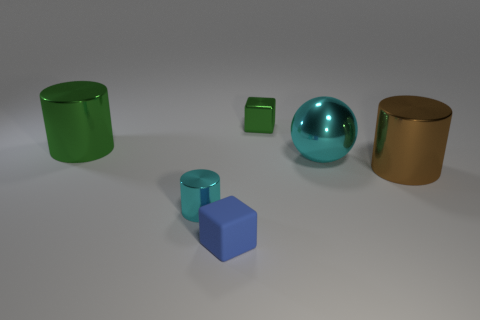Subtract all green metal cylinders. How many cylinders are left? 2 Subtract all blue blocks. How many blocks are left? 1 Add 2 purple matte spheres. How many objects exist? 8 Subtract all balls. How many objects are left? 5 Subtract 2 cubes. How many cubes are left? 0 Subtract all brown blocks. Subtract all red spheres. How many blocks are left? 2 Subtract all purple balls. How many cyan blocks are left? 0 Subtract all brown things. Subtract all big green metal cylinders. How many objects are left? 4 Add 6 large brown shiny things. How many large brown shiny things are left? 7 Add 2 shiny things. How many shiny things exist? 7 